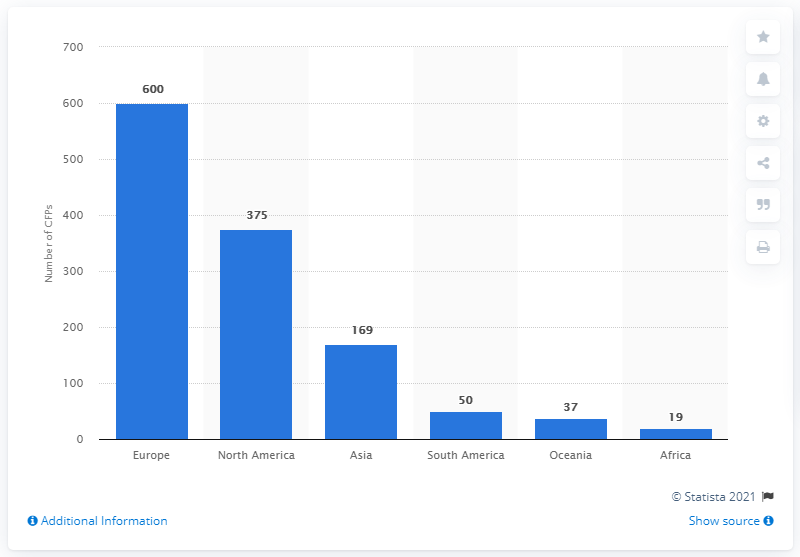Identify some key points in this picture. There were 375 crowdfunding platforms in North America in 2014. 